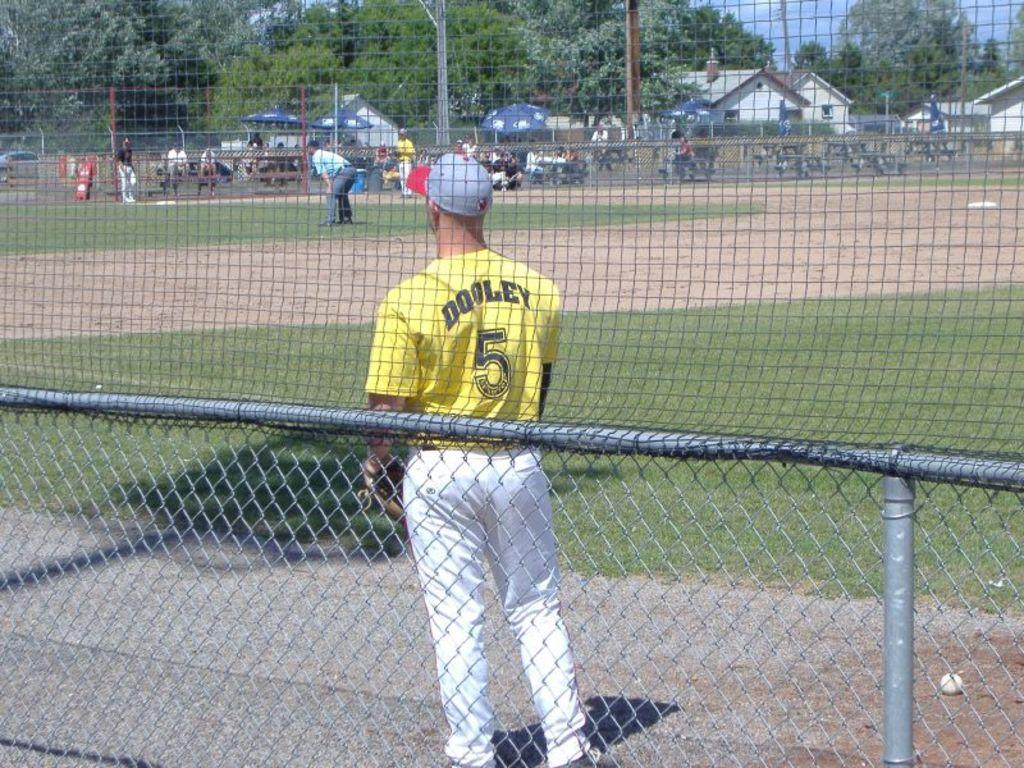<image>
Share a concise interpretation of the image provided. Player Dooley is number 5, and he's wearing a yellow shirt and a blue and red cap. 